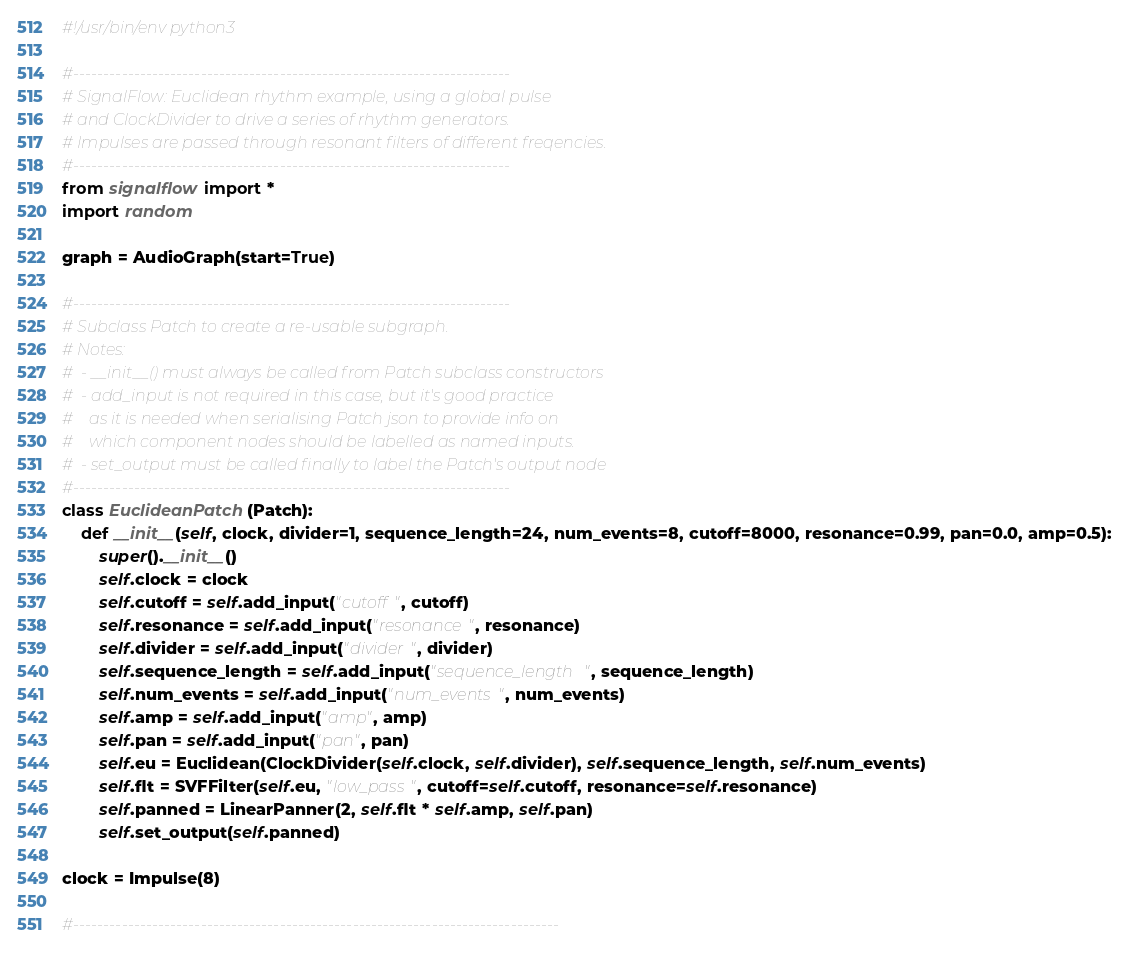<code> <loc_0><loc_0><loc_500><loc_500><_Python_>#!/usr/bin/env python3

#------------------------------------------------------------------------
# SignalFlow: Euclidean rhythm example, using a global pulse
# and ClockDivider to drive a series of rhythm generators.
# Impulses are passed through resonant filters of different freqencies.
#------------------------------------------------------------------------
from signalflow import *
import random

graph = AudioGraph(start=True)

#------------------------------------------------------------------------
# Subclass Patch to create a re-usable subgraph.
# Notes:
#  - __init__() must always be called from Patch subclass constructors
#  - add_input is not required in this case, but it's good practice
#    as it is needed when serialising Patch json to provide info on
#    which component nodes should be labelled as named inputs.
#  - set_output must be called finally to label the Patch's output node
#------------------------------------------------------------------------
class EuclideanPatch (Patch):
    def __init__(self, clock, divider=1, sequence_length=24, num_events=8, cutoff=8000, resonance=0.99, pan=0.0, amp=0.5):
        super().__init__()
        self.clock = clock
        self.cutoff = self.add_input("cutoff", cutoff)
        self.resonance = self.add_input("resonance", resonance)
        self.divider = self.add_input("divider", divider)
        self.sequence_length = self.add_input("sequence_length", sequence_length)
        self.num_events = self.add_input("num_events", num_events)
        self.amp = self.add_input("amp", amp)
        self.pan = self.add_input("pan", pan)
        self.eu = Euclidean(ClockDivider(self.clock, self.divider), self.sequence_length, self.num_events)
        self.flt = SVFFilter(self.eu, "low_pass", cutoff=self.cutoff, resonance=self.resonance)
        self.panned = LinearPanner(2, self.flt * self.amp, self.pan)
        self.set_output(self.panned)

clock = Impulse(8)

#--------------------------------------------------------------------------------</code> 